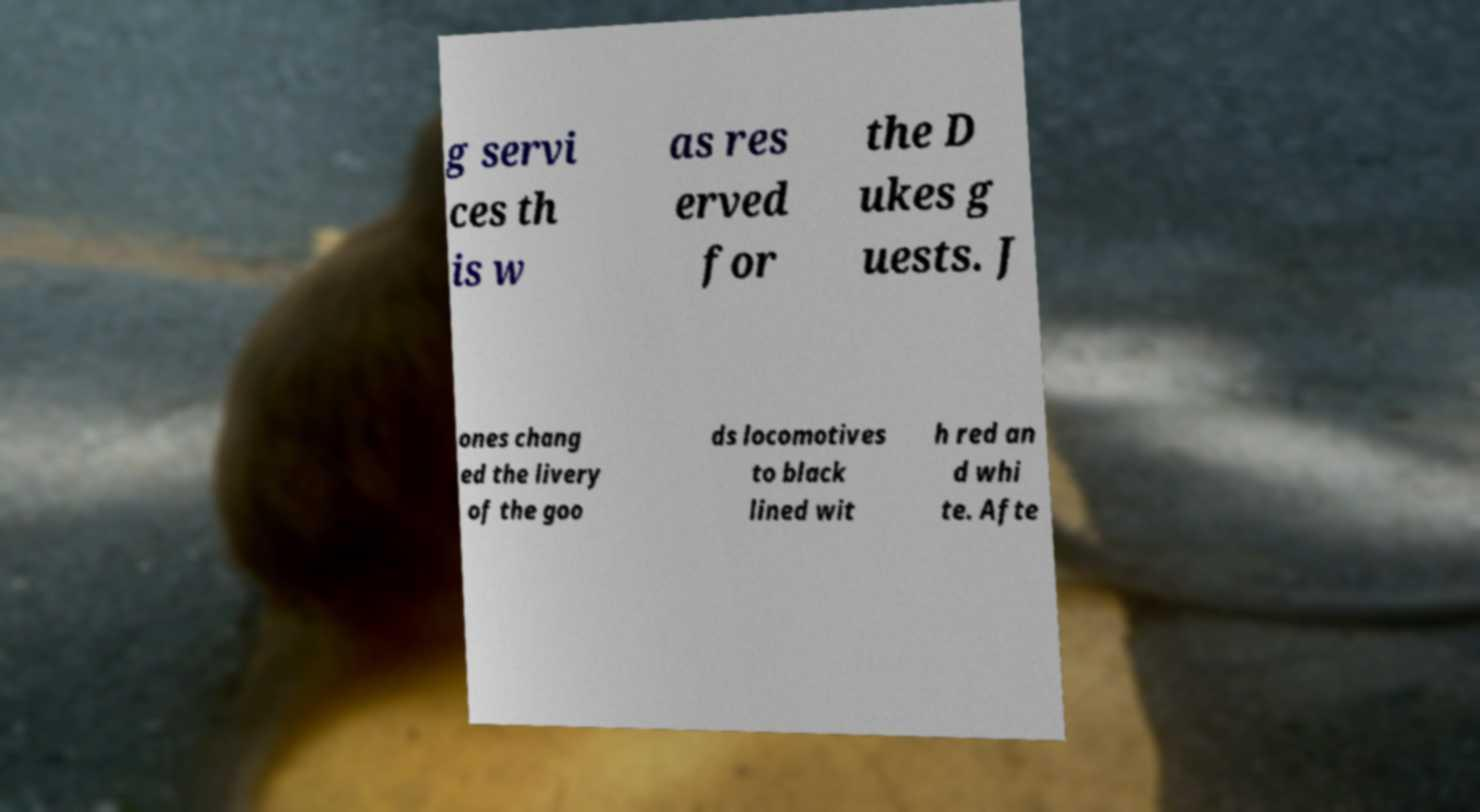I need the written content from this picture converted into text. Can you do that? g servi ces th is w as res erved for the D ukes g uests. J ones chang ed the livery of the goo ds locomotives to black lined wit h red an d whi te. Afte 